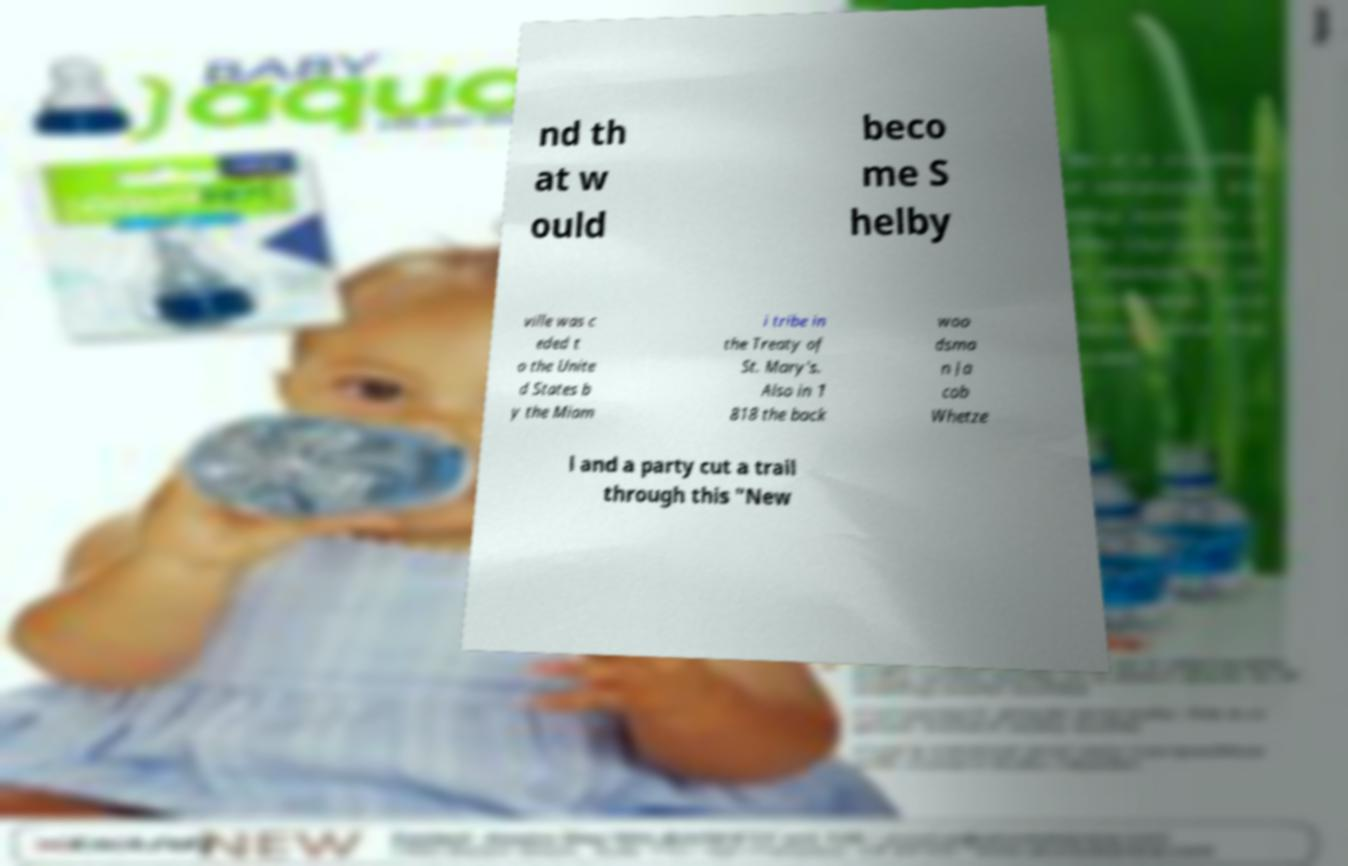Can you read and provide the text displayed in the image?This photo seems to have some interesting text. Can you extract and type it out for me? nd th at w ould beco me S helby ville was c eded t o the Unite d States b y the Miam i tribe in the Treaty of St. Mary's. Also in 1 818 the back woo dsma n Ja cob Whetze l and a party cut a trail through this "New 